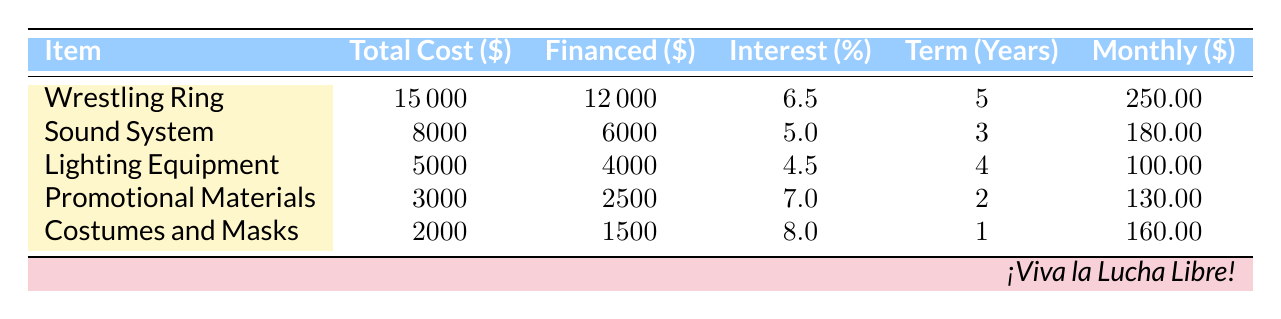What is the total cost of the Wrestling Ring? From the table, the total cost of the Wrestling Ring is clearly listed as $15000.
Answer: 15000 What is the interest rate on the Lighting Equipment? The interest rate for the Lighting Equipment is specified in the table as 4.5%.
Answer: 4.5 How much is the financed amount for the Sound System? According to the table, the financed amount for the Sound System is $6000.
Answer: 6000 Which item has the highest interest rate? To find the item with the highest interest rate, we compare the rates listed: 6.5% (Wrestling Ring), 5.0% (Sound System), 4.5% (Lighting Equipment), 7.0% (Promotional Materials), and 8.0% (Costumes and Masks). The Costumes and Masks have the highest rate at 8.0%.
Answer: Costumes and Masks What is the average monthly payment for all items? First, we add up the monthly payments: 250 + 180 + 100 + 130 + 160 = 820. There are 5 items, so the average is 820 / 5 = 164.
Answer: 164 Is the total cost of Promotional Materials greater than that of Costumes and Masks? The table shows the total cost of Promotional Materials is $3000 and that of Costumes and Masks is $2000. Since 3000 is greater than 2000, the statement is true.
Answer: Yes What is the total financed amount for all items combined? We sum the financed amounts listed: 12000 (Wrestling Ring) + 6000 (Sound System) + 4000 (Lighting Equipment) + 2500 (Promotional Materials) + 1500 (Costumes and Masks) = 25000.
Answer: 25000 If I pay only the minimum monthly payments, how much total will I pay over the term of the costumes and masks financing? The monthly payment for Costumes and Masks is $160, and the term is 1 year (12 months). Thus, the total payment will be 160 * 12 = 1920.
Answer: 1920 Which equipment has the lowest monthly payment? By comparing the monthly payments: $250 (Wrestling Ring), $180 (Sound System), $100 (Lighting Equipment), $130 (Promotional Materials), and $160 (Costumes and Masks), we see that Lighting Equipment has the lowest payment at $100.
Answer: Lighting Equipment How many items have a financed amount less than $2000? Looking at the financed amounts: $12000, $6000, $4000, $2500, and $1500, we see that only the Costumes and Masks are below $2000 ($1500). Therefore, there is 1 item.
Answer: 1 